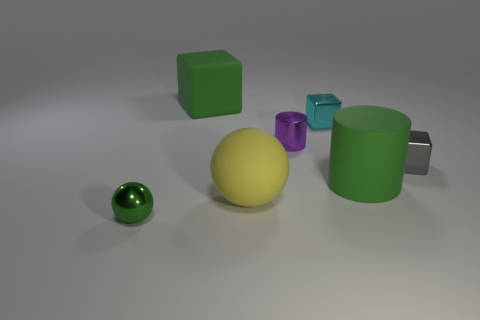What is the material of the tiny cube that is behind the cylinder that is behind the tiny block on the right side of the big matte cylinder?
Offer a terse response. Metal. How many other things are the same material as the small cylinder?
Keep it short and to the point. 3. There is a metal cylinder that is in front of the small cyan thing; what number of objects are behind it?
Make the answer very short. 2. What number of blocks are big purple objects or large yellow rubber objects?
Your answer should be compact. 0. There is a small metallic thing that is in front of the small purple metal cylinder and behind the small metallic ball; what is its color?
Give a very brief answer. Gray. Is there any other thing that has the same color as the tiny cylinder?
Give a very brief answer. No. There is a small shiny thing to the left of the ball that is behind the small green sphere; what is its color?
Give a very brief answer. Green. Do the yellow rubber object and the matte cylinder have the same size?
Keep it short and to the point. Yes. Is the big green object behind the gray object made of the same material as the cylinder that is on the right side of the small purple cylinder?
Make the answer very short. Yes. What is the shape of the large green rubber object in front of the small block that is behind the block right of the cyan metallic block?
Your response must be concise. Cylinder. 